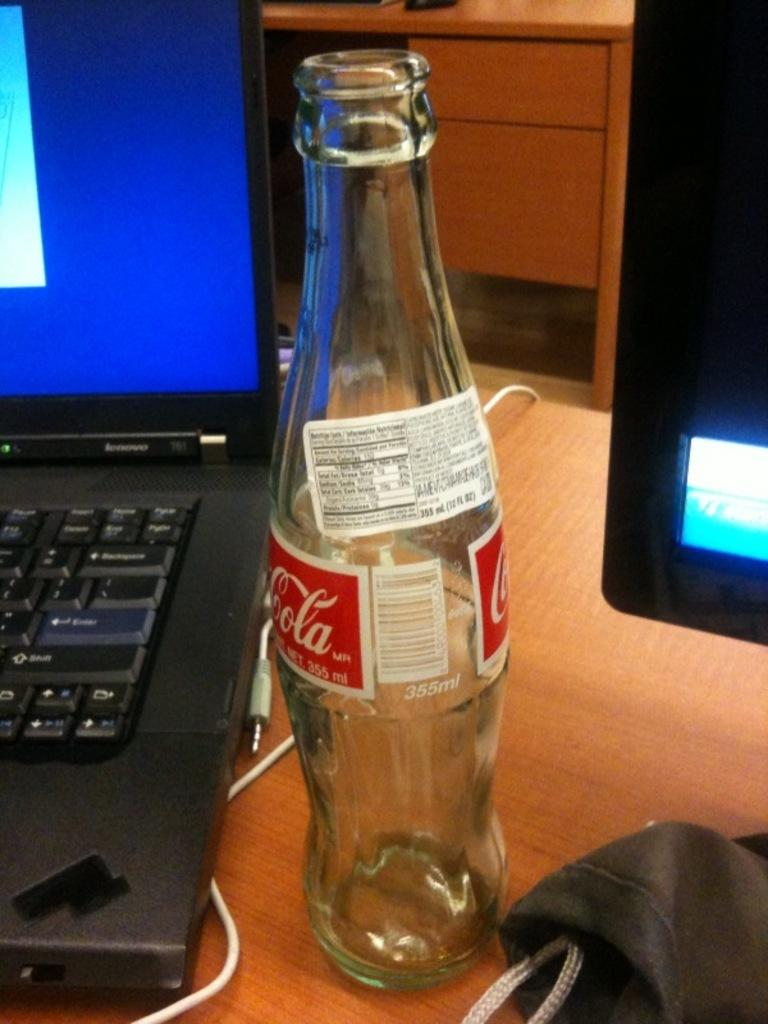<image>
Provide a brief description of the given image. Laqptop with a coca cola bottle that is empty beside it 